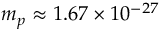<formula> <loc_0><loc_0><loc_500><loc_500>m _ { p } \approx 1 . 6 7 \times 1 0 ^ { - 2 7 }</formula> 